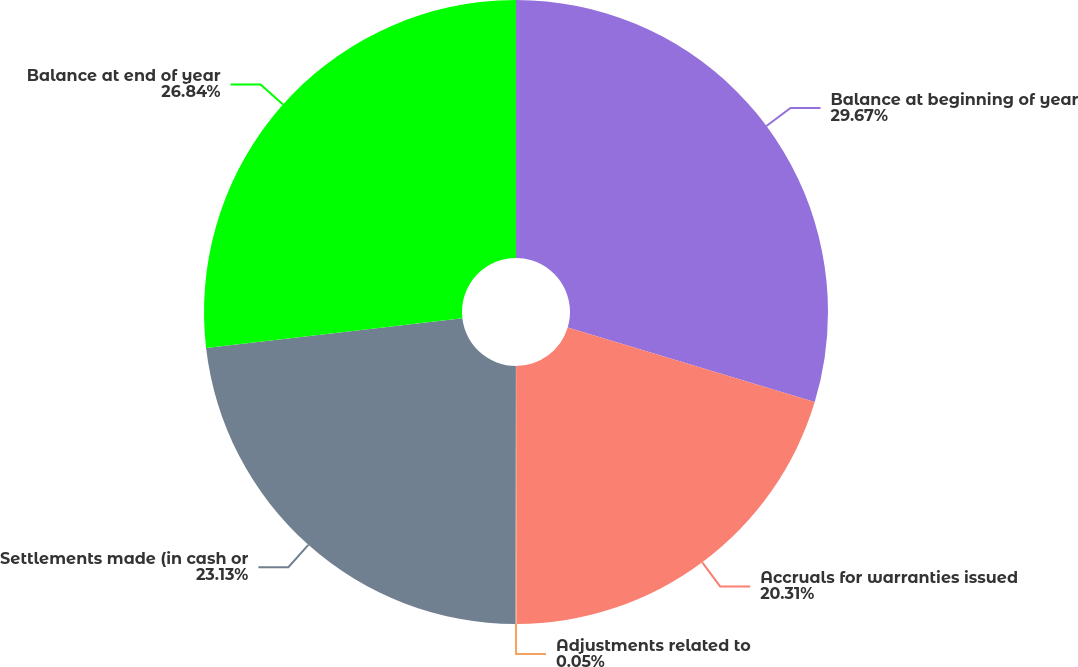Convert chart. <chart><loc_0><loc_0><loc_500><loc_500><pie_chart><fcel>Balance at beginning of year<fcel>Accruals for warranties issued<fcel>Adjustments related to<fcel>Settlements made (in cash or<fcel>Balance at end of year<nl><fcel>29.66%<fcel>20.31%<fcel>0.05%<fcel>23.13%<fcel>26.84%<nl></chart> 